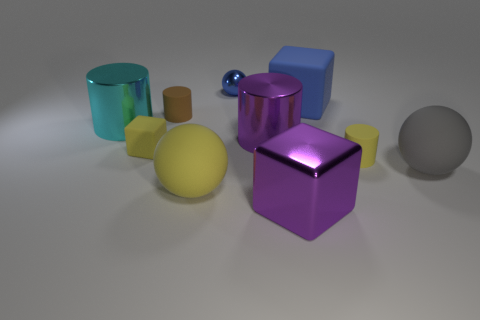Subtract all matte spheres. How many spheres are left? 1 Subtract 1 cylinders. How many cylinders are left? 3 Subtract all gray cylinders. Subtract all yellow blocks. How many cylinders are left? 4 Subtract all cylinders. How many objects are left? 6 Subtract 1 purple cylinders. How many objects are left? 9 Subtract all large purple shiny cylinders. Subtract all large metallic cylinders. How many objects are left? 7 Add 6 tiny metal spheres. How many tiny metal spheres are left? 7 Add 7 small gray rubber spheres. How many small gray rubber spheres exist? 7 